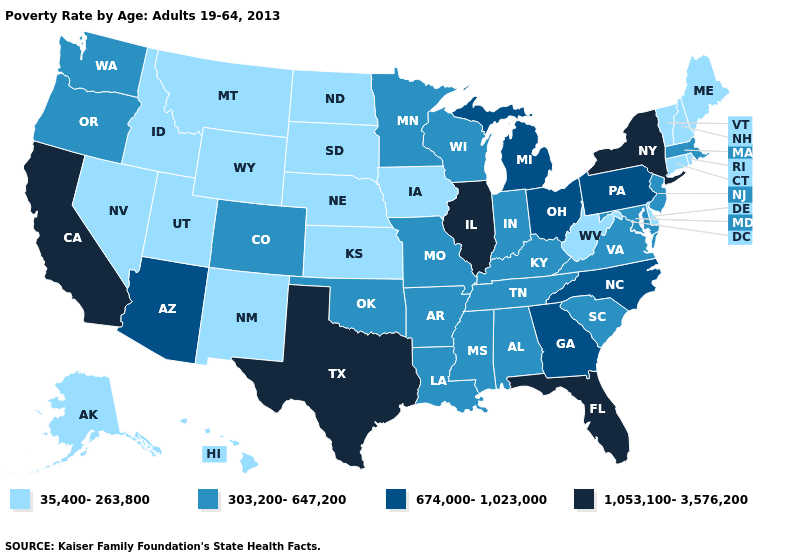Does Florida have the lowest value in the USA?
Give a very brief answer. No. What is the lowest value in the South?
Be succinct. 35,400-263,800. What is the lowest value in states that border Oregon?
Give a very brief answer. 35,400-263,800. Name the states that have a value in the range 674,000-1,023,000?
Give a very brief answer. Arizona, Georgia, Michigan, North Carolina, Ohio, Pennsylvania. What is the value of Vermont?
Be succinct. 35,400-263,800. What is the value of Connecticut?
Short answer required. 35,400-263,800. Is the legend a continuous bar?
Concise answer only. No. What is the lowest value in states that border Utah?
Short answer required. 35,400-263,800. What is the value of New York?
Answer briefly. 1,053,100-3,576,200. Does Delaware have the lowest value in the USA?
Answer briefly. Yes. What is the value of Iowa?
Be succinct. 35,400-263,800. What is the lowest value in states that border Mississippi?
Be succinct. 303,200-647,200. What is the highest value in the USA?
Write a very short answer. 1,053,100-3,576,200. What is the highest value in states that border Rhode Island?
Write a very short answer. 303,200-647,200. Does Rhode Island have the highest value in the USA?
Keep it brief. No. 